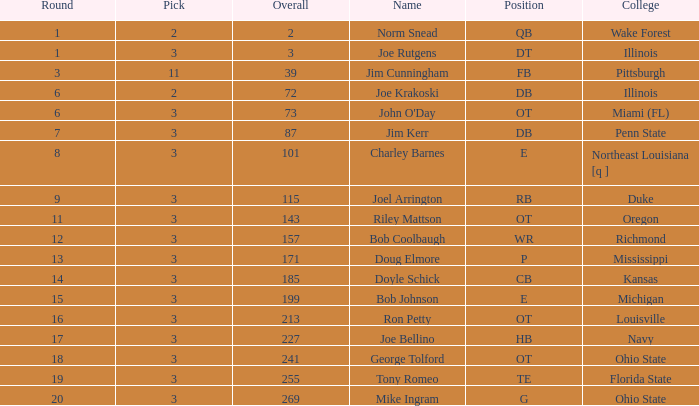How many overalls are there with the name charley barnes and a pick number below 3? None. 